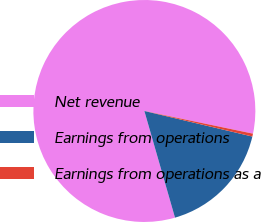Convert chart. <chart><loc_0><loc_0><loc_500><loc_500><pie_chart><fcel>Net revenue<fcel>Earnings from operations<fcel>Earnings from operations as a<nl><fcel>82.73%<fcel>16.85%<fcel>0.42%<nl></chart> 